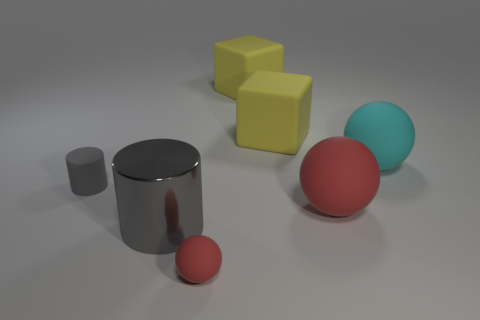What material is the ball that is the same size as the cyan object?
Offer a very short reply. Rubber. Does the big sphere to the left of the large cyan rubber thing have the same material as the cylinder on the right side of the gray matte cylinder?
Offer a terse response. No. There is a red object that is the same size as the cyan matte sphere; what is its shape?
Your answer should be compact. Sphere. There is a large rubber ball that is behind the gray matte cylinder; what is its color?
Your response must be concise. Cyan. What number of other objects are the same material as the big gray thing?
Your answer should be very brief. 0. Is the number of big gray metallic objects right of the tiny red rubber ball greater than the number of tiny matte things that are to the right of the cyan thing?
Ensure brevity in your answer.  No. What number of red matte spheres are on the right side of the small red rubber ball?
Give a very brief answer. 1. Are the big cyan object and the large sphere that is in front of the large cyan object made of the same material?
Offer a very short reply. Yes. Is there anything else that is the same shape as the big gray metallic object?
Offer a very short reply. Yes. Do the cyan ball and the small cylinder have the same material?
Provide a succinct answer. Yes. 